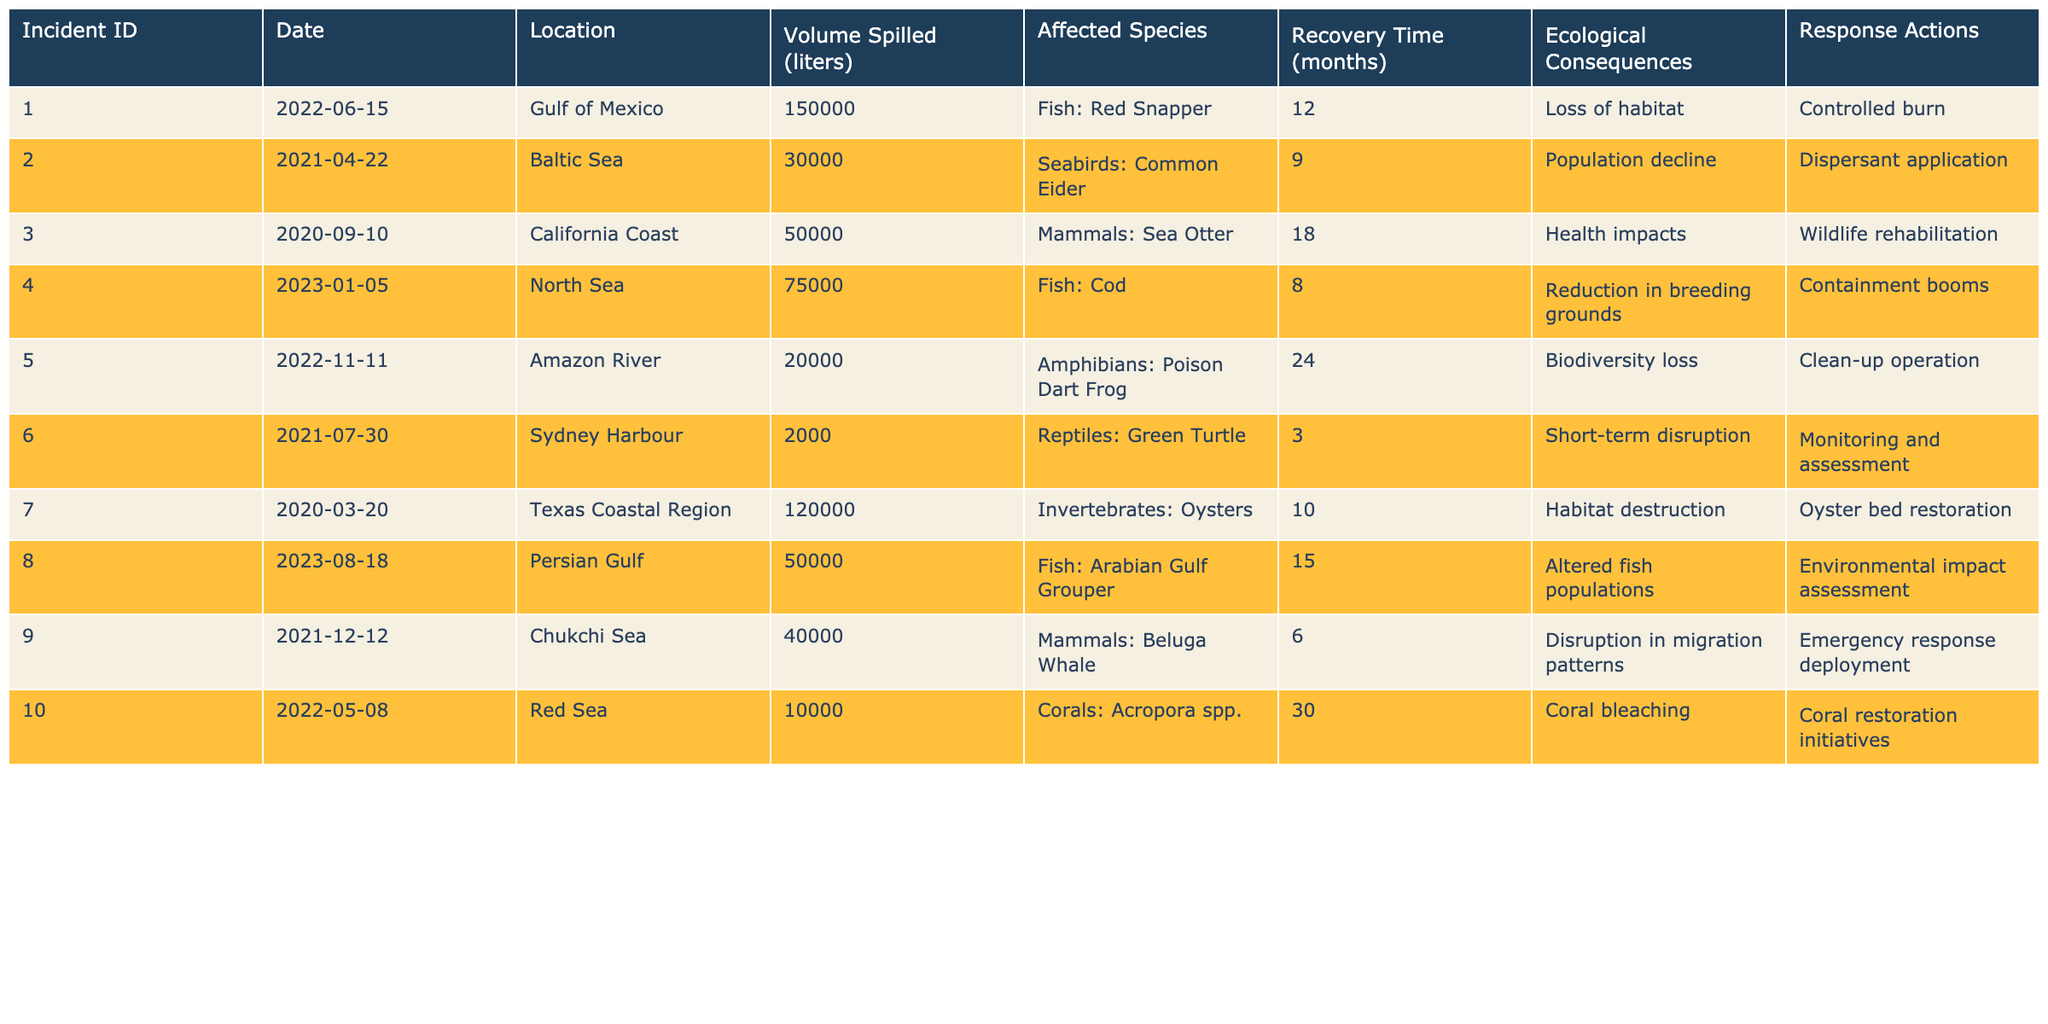What is the volume of the largest spill reported? The table lists the volume spilled for each incident. The largest recorded volume is 150,000 liters in Incident ID 001.
Answer: 150,000 liters How many months did it take for the Sea Otter population to recover? The recovery time for the Sea Otter, affected by Incident ID 003, is given in the table as 18 months.
Answer: 18 months Which incident resulted in habitat destruction and where did it occur? Incident ID 007 involved habitat destruction with a spill in the Texas Coastal Region.
Answer: Texas Coastal Region What is the average recovery time for all incidents listed? To calculate the average recovery time, we sum all recovery times (12 + 9 + 18 + 8 + 24 + 3 + 10 + 15 + 6 + 30 = 135) and divide by the number of incidents (10). So, 135/10 = 13.5 months.
Answer: 13.5 months Was there an incident that caused biodiversity loss and what was its affected species? Yes, Incident ID 005 caused biodiversity loss, affecting the Poison Dart Frog.
Answer: Yes, Poison Dart Frog How many incidents affected fish species? By reviewing the table, fish species are listed as affected in incidents 001, 004, 008, totaling 3 incidents.
Answer: 3 incidents Which incident had the shortest recovery time and what was the response action taken? The shortest recovery time is 3 months for Incident ID 006, which involved monitoring and assessment as the response action.
Answer: Incident ID 006, monitoring and assessment Is there a correlation between the volume of oil spilled and the recovery time? A review of the data shows that higher spill volumes do not consistently relate to longer recovery times; thus, we conclude that the correlation is weak.
Answer: Weak correlation What was the ecological consequence reported for the spill incident in the Red Sea? The table indicates that the ecological consequence for the spill in the Red Sea (Incident ID 010) was coral bleaching.
Answer: Coral bleaching How many months did it take for the affected species in the Amazon River to recover? The table specifies that the recovery time for the species affected in the Amazon River (Incident ID 005) was 24 months.
Answer: 24 months 